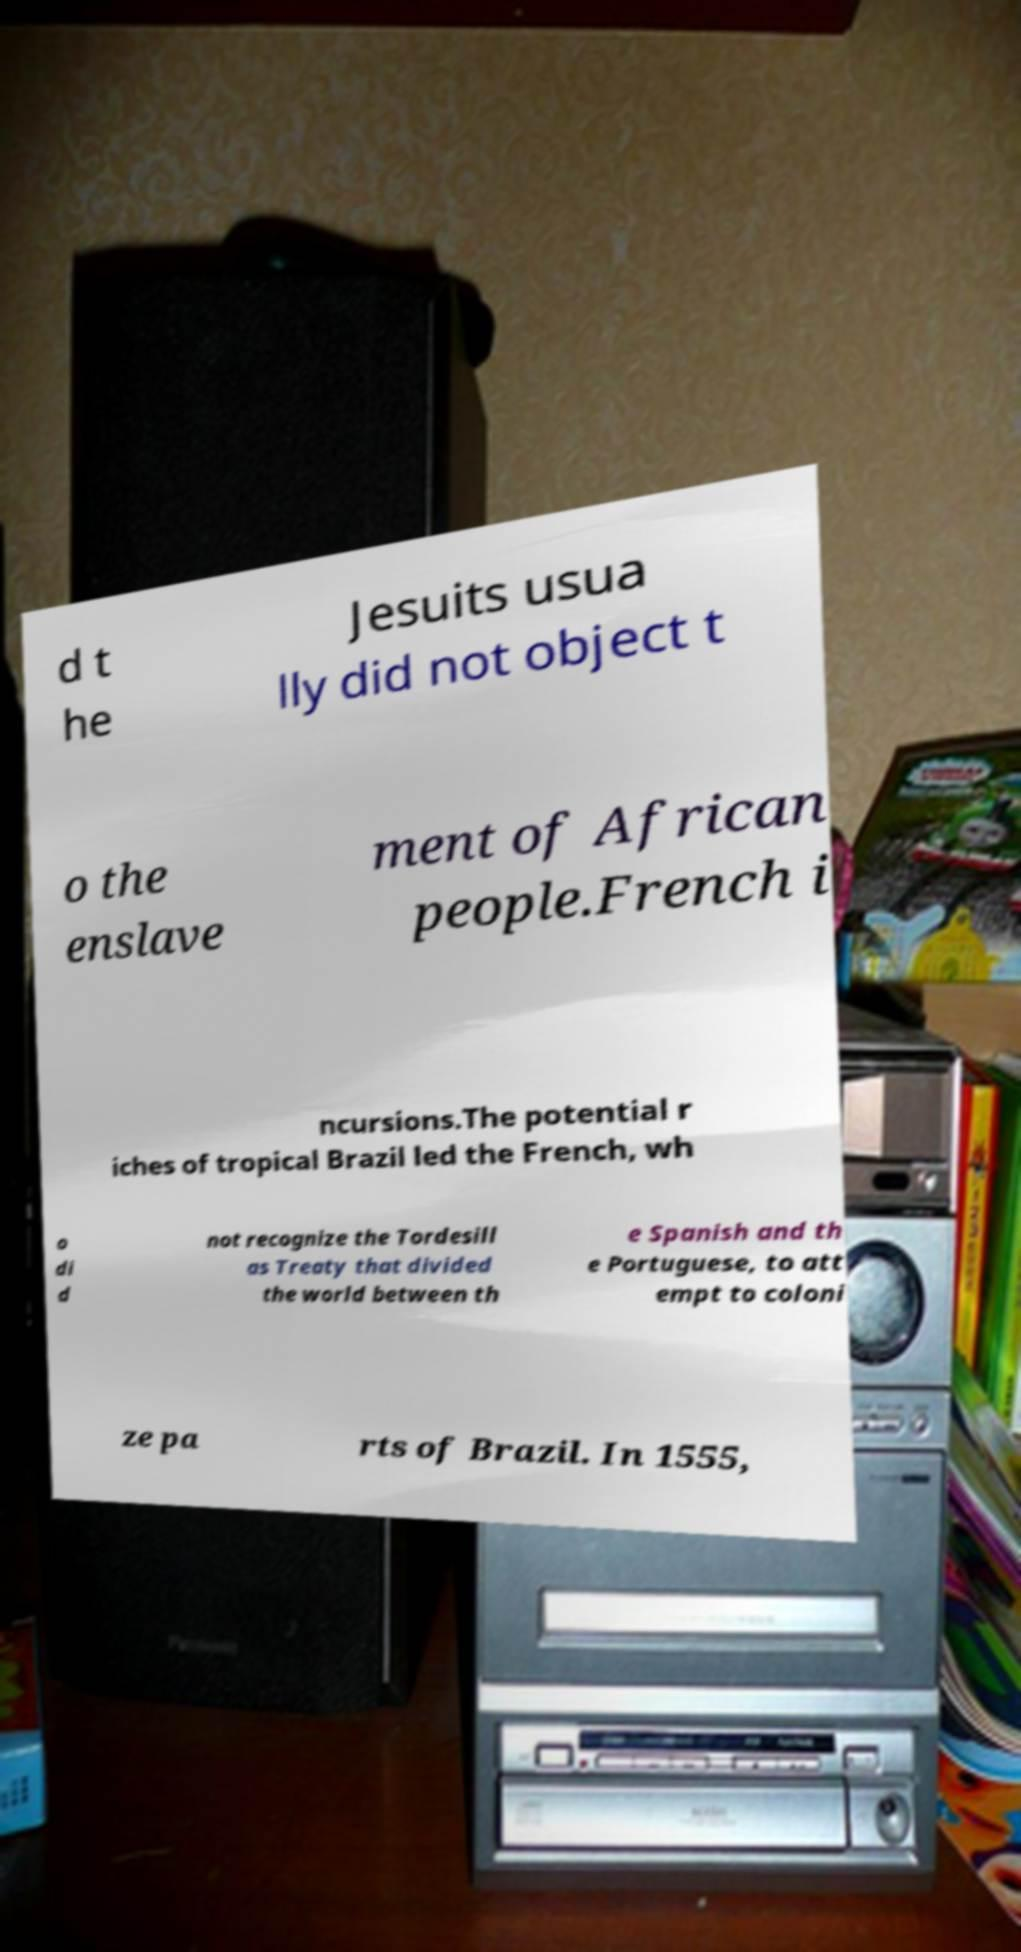Can you read and provide the text displayed in the image?This photo seems to have some interesting text. Can you extract and type it out for me? d t he Jesuits usua lly did not object t o the enslave ment of African people.French i ncursions.The potential r iches of tropical Brazil led the French, wh o di d not recognize the Tordesill as Treaty that divided the world between th e Spanish and th e Portuguese, to att empt to coloni ze pa rts of Brazil. In 1555, 